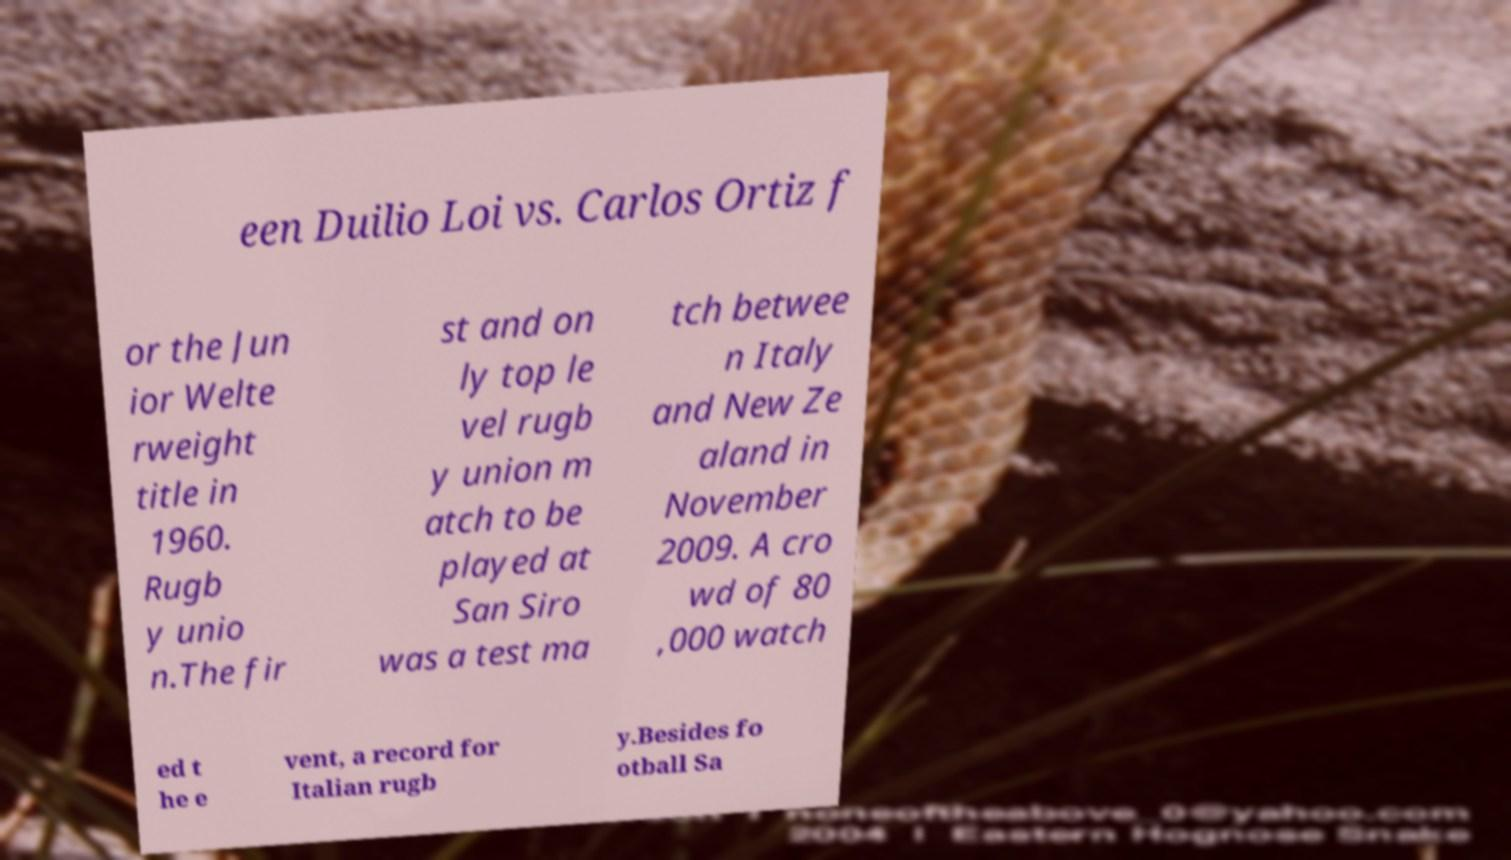I need the written content from this picture converted into text. Can you do that? een Duilio Loi vs. Carlos Ortiz f or the Jun ior Welte rweight title in 1960. Rugb y unio n.The fir st and on ly top le vel rugb y union m atch to be played at San Siro was a test ma tch betwee n Italy and New Ze aland in November 2009. A cro wd of 80 ,000 watch ed t he e vent, a record for Italian rugb y.Besides fo otball Sa 